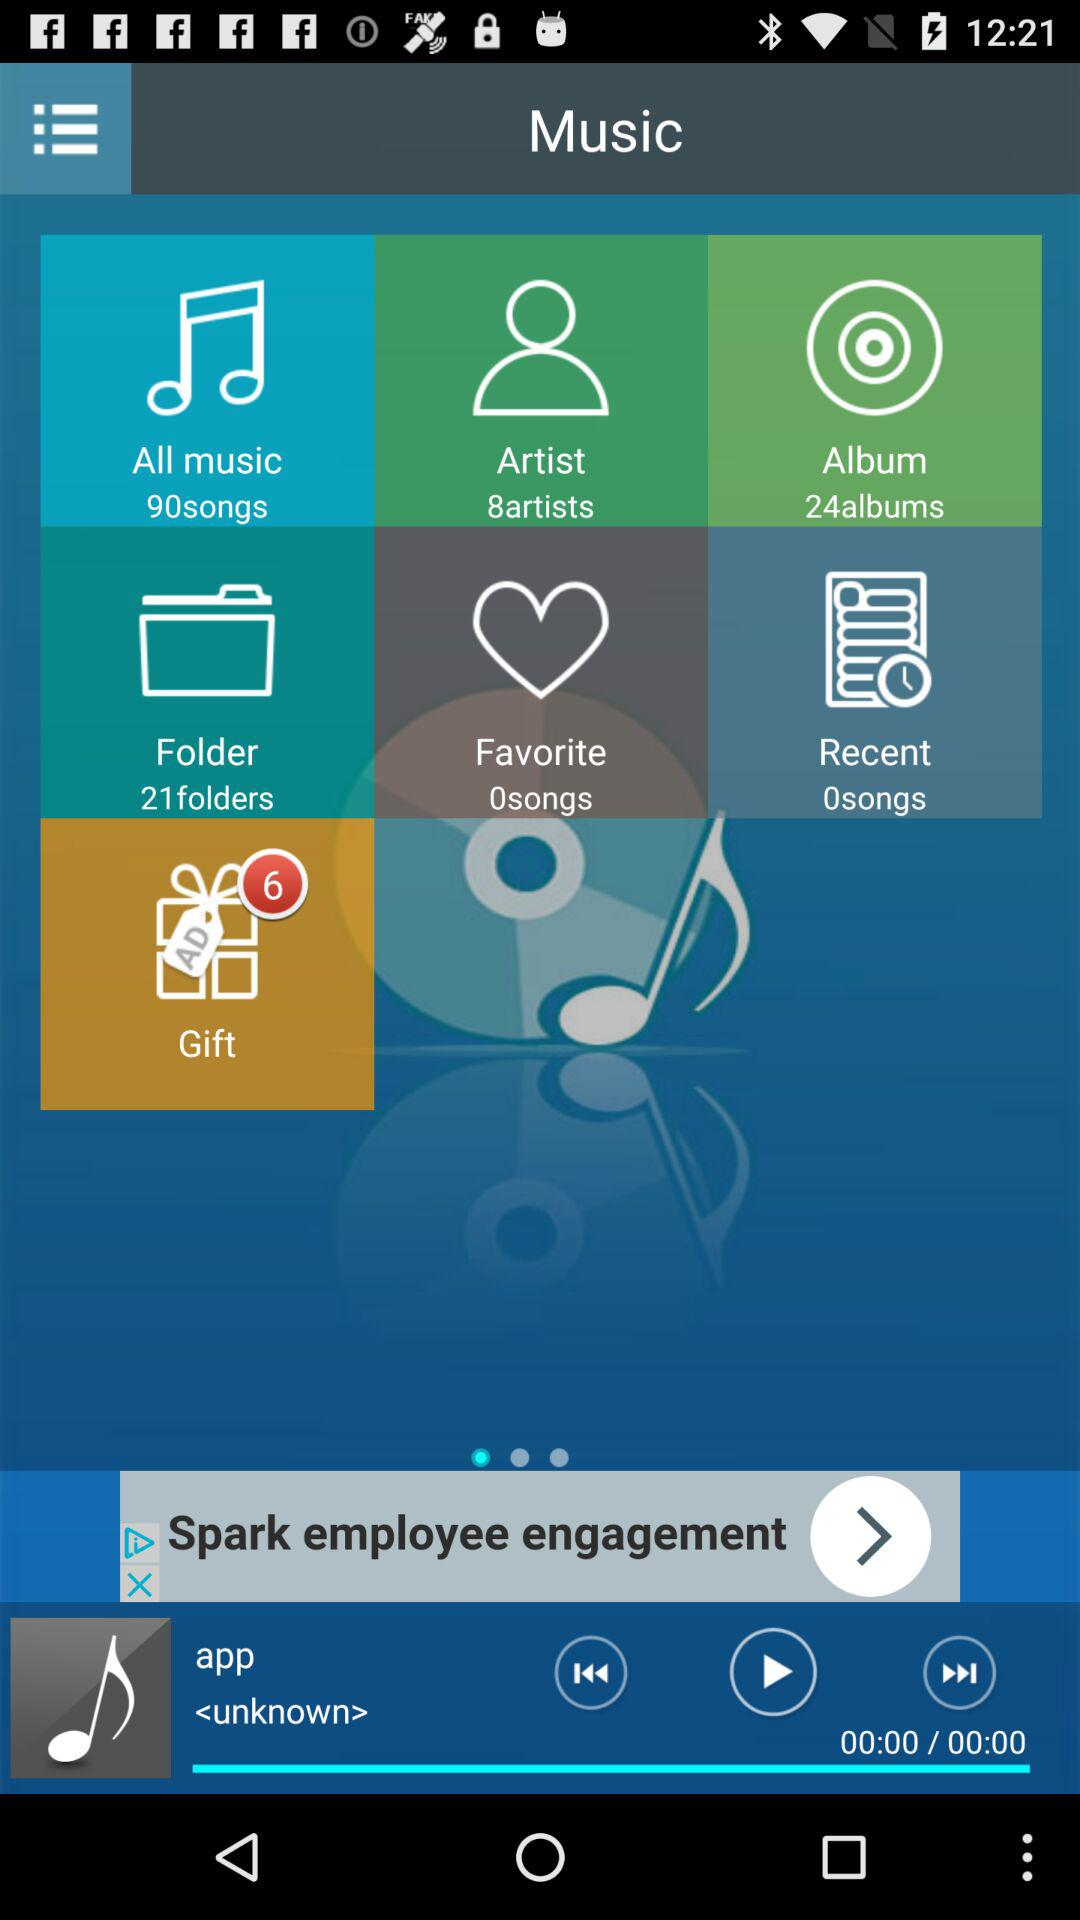What folder has 0 songs? The folders are: "Favorite" and "Recent". 